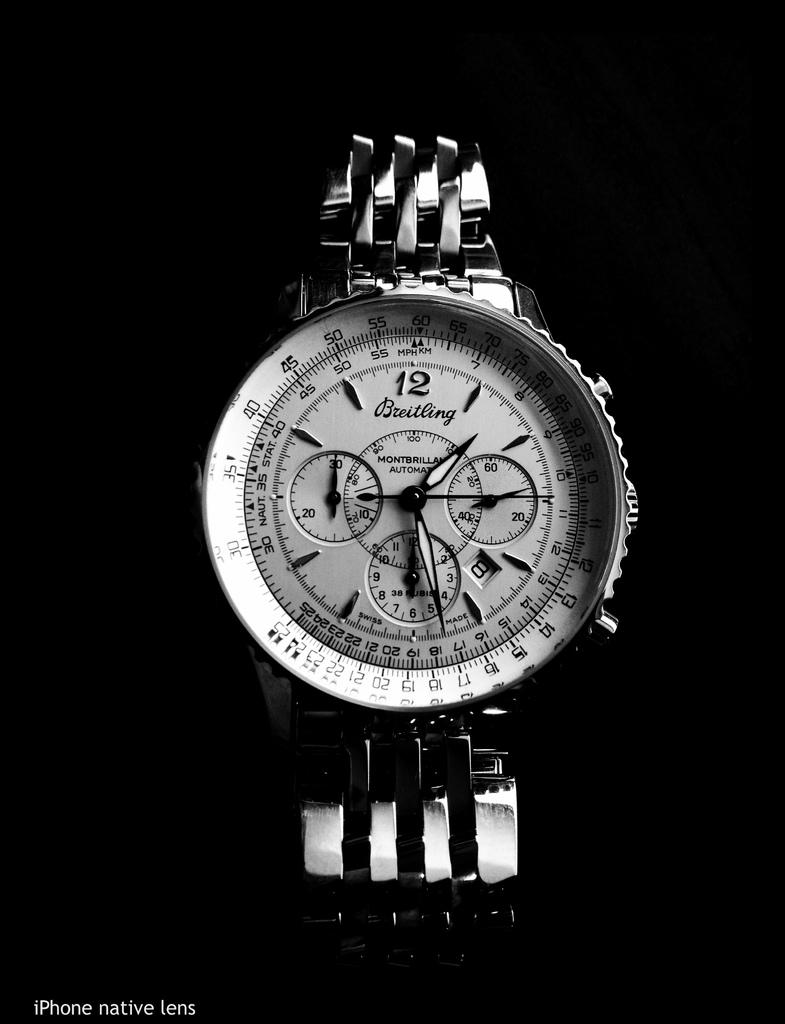<image>
Share a concise interpretation of the image provided. A close up of a Breitling watch made by Montbrilliant 